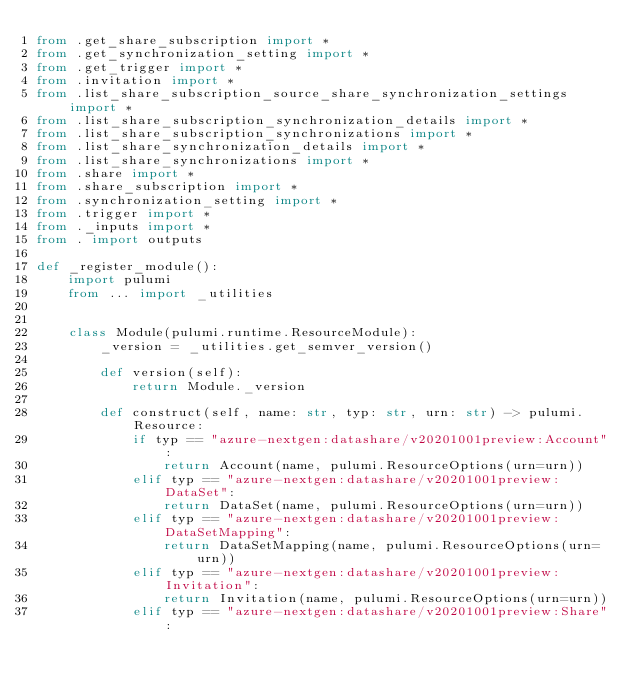<code> <loc_0><loc_0><loc_500><loc_500><_Python_>from .get_share_subscription import *
from .get_synchronization_setting import *
from .get_trigger import *
from .invitation import *
from .list_share_subscription_source_share_synchronization_settings import *
from .list_share_subscription_synchronization_details import *
from .list_share_subscription_synchronizations import *
from .list_share_synchronization_details import *
from .list_share_synchronizations import *
from .share import *
from .share_subscription import *
from .synchronization_setting import *
from .trigger import *
from ._inputs import *
from . import outputs

def _register_module():
    import pulumi
    from ... import _utilities


    class Module(pulumi.runtime.ResourceModule):
        _version = _utilities.get_semver_version()

        def version(self):
            return Module._version

        def construct(self, name: str, typ: str, urn: str) -> pulumi.Resource:
            if typ == "azure-nextgen:datashare/v20201001preview:Account":
                return Account(name, pulumi.ResourceOptions(urn=urn))
            elif typ == "azure-nextgen:datashare/v20201001preview:DataSet":
                return DataSet(name, pulumi.ResourceOptions(urn=urn))
            elif typ == "azure-nextgen:datashare/v20201001preview:DataSetMapping":
                return DataSetMapping(name, pulumi.ResourceOptions(urn=urn))
            elif typ == "azure-nextgen:datashare/v20201001preview:Invitation":
                return Invitation(name, pulumi.ResourceOptions(urn=urn))
            elif typ == "azure-nextgen:datashare/v20201001preview:Share":</code> 